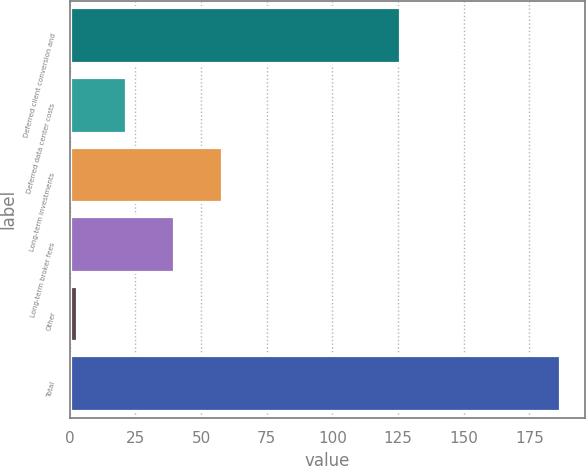Convert chart to OTSL. <chart><loc_0><loc_0><loc_500><loc_500><bar_chart><fcel>Deferred client conversion and<fcel>Deferred data center costs<fcel>Long-term investments<fcel>Long-term broker fees<fcel>Other<fcel>Total<nl><fcel>125.8<fcel>21.28<fcel>58.04<fcel>39.66<fcel>2.9<fcel>186.7<nl></chart> 